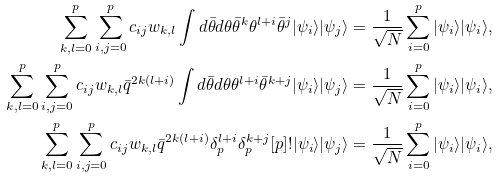Convert formula to latex. <formula><loc_0><loc_0><loc_500><loc_500>\sum _ { k , l = 0 } ^ { p } \sum _ { i , j = 0 } ^ { p } c _ { i j } w _ { k , l } \int d \bar { \theta } d \theta \bar { \theta } ^ { k } \theta ^ { l + i } \bar { \theta } ^ { j } | \psi _ { i } \rangle | \psi _ { j } \rangle = \frac { 1 } { \sqrt { N } } \sum _ { i = 0 } ^ { p } | \psi _ { i } \rangle | \psi _ { i } \rangle , \\ \sum _ { k , l = 0 } ^ { p } \sum _ { i , j = 0 } ^ { p } c _ { i j } w _ { k , l } \bar { q } ^ { 2 k ( l + i ) } \int d \bar { \theta } d \theta \theta ^ { l + i } \bar { \theta } ^ { k + j } | \psi _ { i } \rangle | \psi _ { j } \rangle = \frac { 1 } { \sqrt { N } } \sum _ { i = 0 } ^ { p } | \psi _ { i } \rangle | \psi _ { i } \rangle , \\ \sum _ { k , l = 0 } ^ { p } \sum _ { i , j = 0 } ^ { p } c _ { i j } w _ { k , l } \bar { q } ^ { 2 k ( l + i ) } \delta ^ { l + i } _ { p } \delta ^ { k + j } _ { p } [ p ] ! | \psi _ { i } \rangle | \psi _ { j } \rangle = \frac { 1 } { \sqrt { N } } \sum _ { i = 0 } ^ { p } | \psi _ { i } \rangle | \psi _ { i } \rangle ,</formula> 